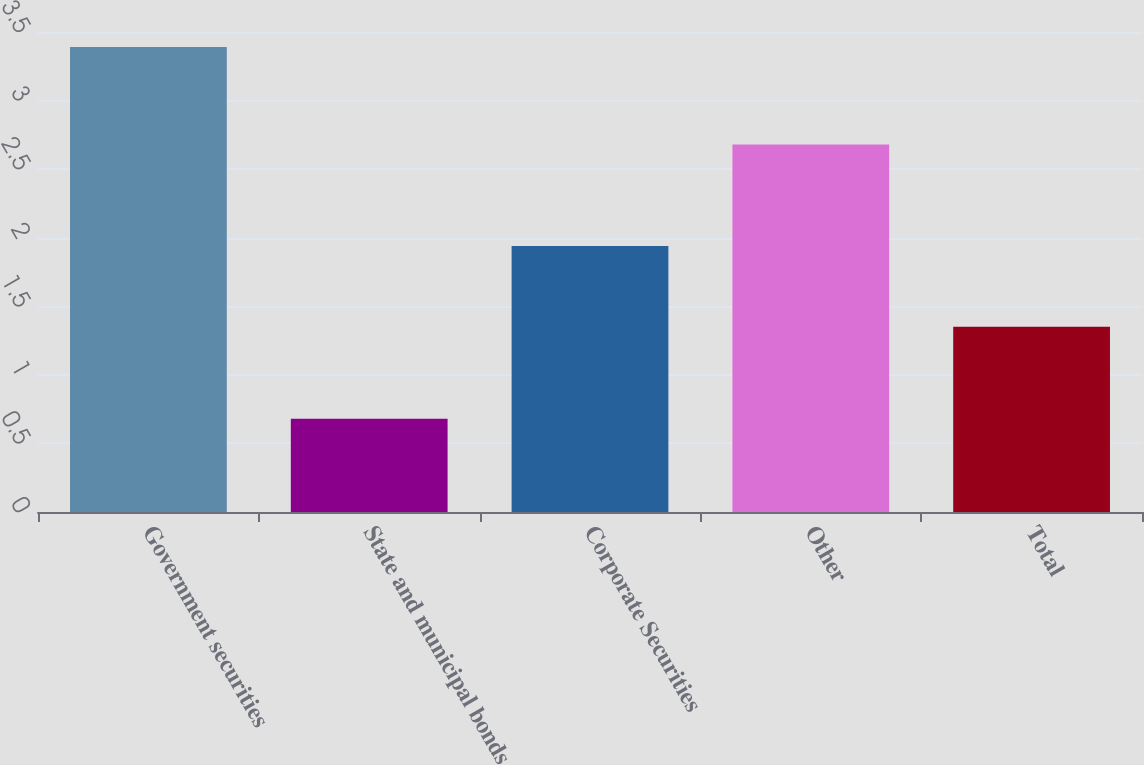Convert chart to OTSL. <chart><loc_0><loc_0><loc_500><loc_500><bar_chart><fcel>Government securities<fcel>State and municipal bonds<fcel>Corporate Securities<fcel>Other<fcel>Total<nl><fcel>3.39<fcel>0.68<fcel>1.94<fcel>2.68<fcel>1.35<nl></chart> 